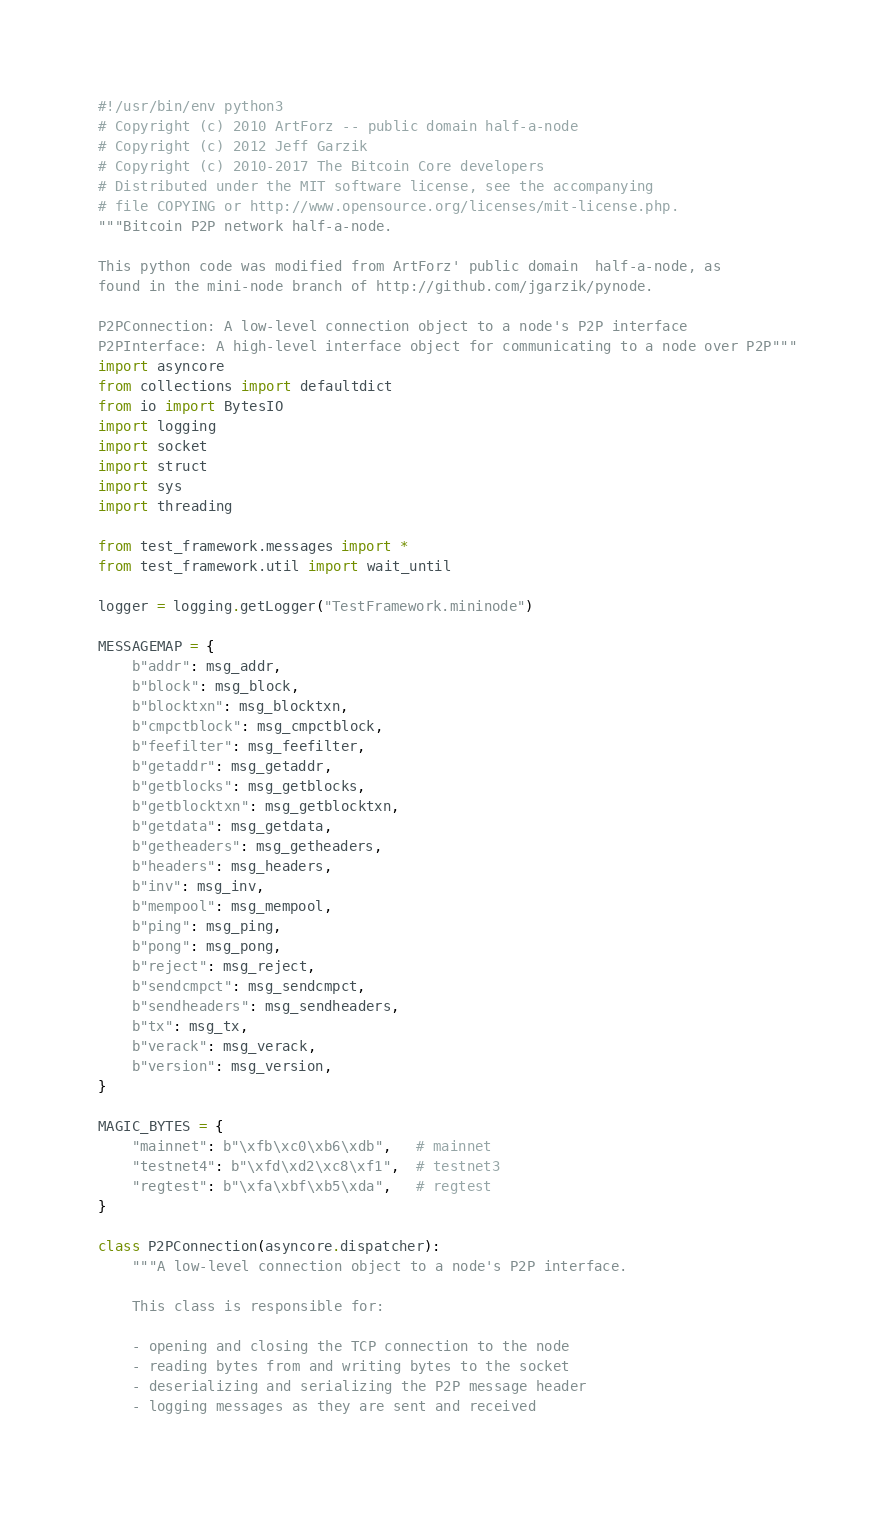Convert code to text. <code><loc_0><loc_0><loc_500><loc_500><_Python_>#!/usr/bin/env python3
# Copyright (c) 2010 ArtForz -- public domain half-a-node
# Copyright (c) 2012 Jeff Garzik
# Copyright (c) 2010-2017 The Bitcoin Core developers
# Distributed under the MIT software license, see the accompanying
# file COPYING or http://www.opensource.org/licenses/mit-license.php.
"""Bitcoin P2P network half-a-node.

This python code was modified from ArtForz' public domain  half-a-node, as
found in the mini-node branch of http://github.com/jgarzik/pynode.

P2PConnection: A low-level connection object to a node's P2P interface
P2PInterface: A high-level interface object for communicating to a node over P2P"""
import asyncore
from collections import defaultdict
from io import BytesIO
import logging
import socket
import struct
import sys
import threading

from test_framework.messages import *
from test_framework.util import wait_until

logger = logging.getLogger("TestFramework.mininode")

MESSAGEMAP = {
    b"addr": msg_addr,
    b"block": msg_block,
    b"blocktxn": msg_blocktxn,
    b"cmpctblock": msg_cmpctblock,
    b"feefilter": msg_feefilter,
    b"getaddr": msg_getaddr,
    b"getblocks": msg_getblocks,
    b"getblocktxn": msg_getblocktxn,
    b"getdata": msg_getdata,
    b"getheaders": msg_getheaders,
    b"headers": msg_headers,
    b"inv": msg_inv,
    b"mempool": msg_mempool,
    b"ping": msg_ping,
    b"pong": msg_pong,
    b"reject": msg_reject,
    b"sendcmpct": msg_sendcmpct,
    b"sendheaders": msg_sendheaders,
    b"tx": msg_tx,
    b"verack": msg_verack,
    b"version": msg_version,
}

MAGIC_BYTES = {
    "mainnet": b"\xfb\xc0\xb6\xdb",   # mainnet
    "testnet4": b"\xfd\xd2\xc8\xf1",  # testnet3
    "regtest": b"\xfa\xbf\xb5\xda",   # regtest
}

class P2PConnection(asyncore.dispatcher):
    """A low-level connection object to a node's P2P interface.

    This class is responsible for:

    - opening and closing the TCP connection to the node
    - reading bytes from and writing bytes to the socket
    - deserializing and serializing the P2P message header
    - logging messages as they are sent and received
</code> 